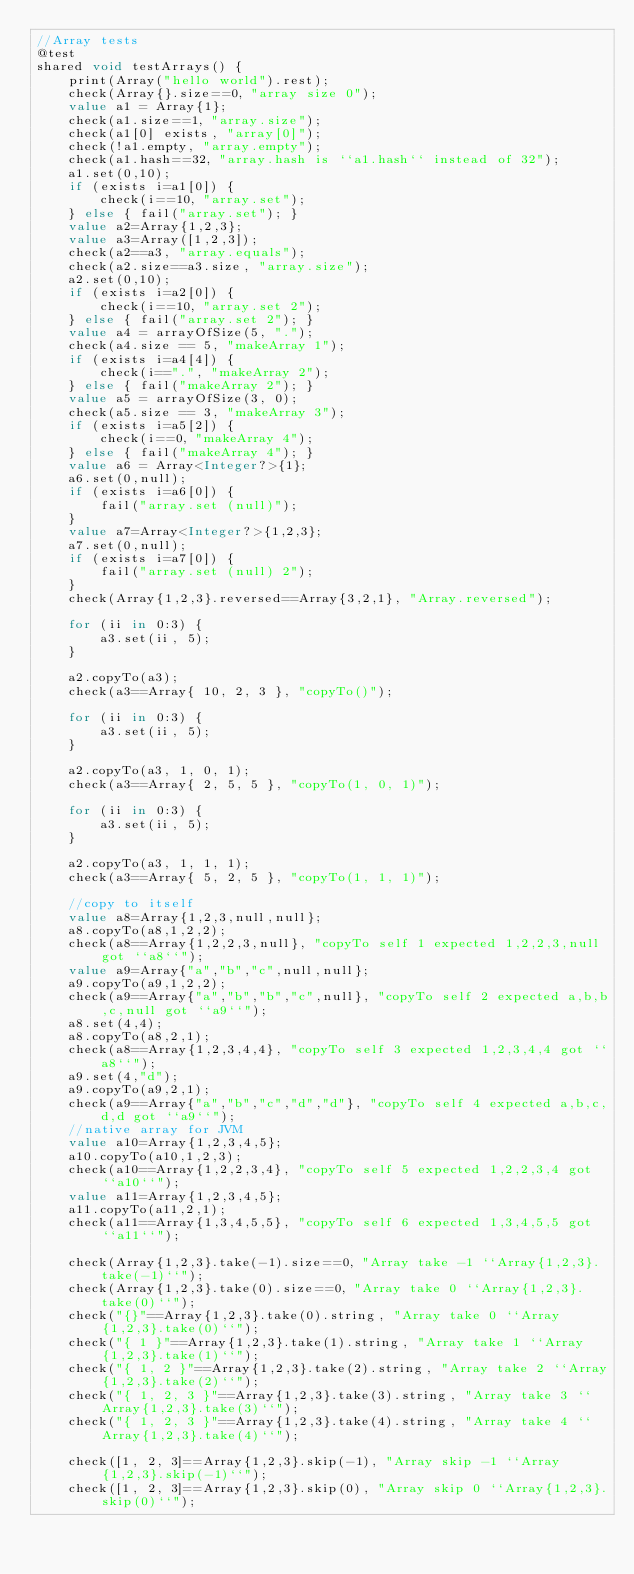Convert code to text. <code><loc_0><loc_0><loc_500><loc_500><_Ceylon_>//Array tests
@test
shared void testArrays() {
    print(Array("hello world").rest);
    check(Array{}.size==0, "array size 0");
    value a1 = Array{1};
    check(a1.size==1, "array.size");
    check(a1[0] exists, "array[0]");
    check(!a1.empty, "array.empty");
    check(a1.hash==32, "array.hash is ``a1.hash`` instead of 32");
    a1.set(0,10);
    if (exists i=a1[0]) {
        check(i==10, "array.set");
    } else { fail("array.set"); }
    value a2=Array{1,2,3};
    value a3=Array([1,2,3]);
    check(a2==a3, "array.equals");
    check(a2.size==a3.size, "array.size");
    a2.set(0,10);
    if (exists i=a2[0]) {
        check(i==10, "array.set 2");
    } else { fail("array.set 2"); }
    value a4 = arrayOfSize(5, ".");
    check(a4.size == 5, "makeArray 1");
    if (exists i=a4[4]) {
        check(i==".", "makeArray 2");
    } else { fail("makeArray 2"); }
    value a5 = arrayOfSize(3, 0);
    check(a5.size == 3, "makeArray 3");
    if (exists i=a5[2]) {
        check(i==0, "makeArray 4");
    } else { fail("makeArray 4"); }
    value a6 = Array<Integer?>{1};
    a6.set(0,null);
    if (exists i=a6[0]) {
        fail("array.set (null)");
    }
    value a7=Array<Integer?>{1,2,3};
    a7.set(0,null);
    if (exists i=a7[0]) {
        fail("array.set (null) 2");
    }
    check(Array{1,2,3}.reversed==Array{3,2,1}, "Array.reversed");
    
    for (ii in 0:3) {
        a3.set(ii, 5);
    }
    
    a2.copyTo(a3);
    check(a3==Array{ 10, 2, 3 }, "copyTo()");
    
    for (ii in 0:3) {
        a3.set(ii, 5);
    }
    
    a2.copyTo(a3, 1, 0, 1);
    check(a3==Array{ 2, 5, 5 }, "copyTo(1, 0, 1)");
    
    for (ii in 0:3) {
        a3.set(ii, 5);
    }
    
    a2.copyTo(a3, 1, 1, 1);
    check(a3==Array{ 5, 2, 5 }, "copyTo(1, 1, 1)");

    //copy to itself
    value a8=Array{1,2,3,null,null};
    a8.copyTo(a8,1,2,2);
    check(a8==Array{1,2,2,3,null}, "copyTo self 1 expected 1,2,2,3,null got ``a8``");
    value a9=Array{"a","b","c",null,null};
    a9.copyTo(a9,1,2,2);
    check(a9==Array{"a","b","b","c",null}, "copyTo self 2 expected a,b,b,c,null got ``a9``");
    a8.set(4,4);
    a8.copyTo(a8,2,1);
    check(a8==Array{1,2,3,4,4}, "copyTo self 3 expected 1,2,3,4,4 got ``a8``");
    a9.set(4,"d");
    a9.copyTo(a9,2,1);
    check(a9==Array{"a","b","c","d","d"}, "copyTo self 4 expected a,b,c,d,d got ``a9``");
    //native array for JVM
    value a10=Array{1,2,3,4,5};
    a10.copyTo(a10,1,2,3);
    check(a10==Array{1,2,2,3,4}, "copyTo self 5 expected 1,2,2,3,4 got ``a10``");
    value a11=Array{1,2,3,4,5};
    a11.copyTo(a11,2,1);
    check(a11==Array{1,3,4,5,5}, "copyTo self 6 expected 1,3,4,5,5 got ``a11``");
    
    check(Array{1,2,3}.take(-1).size==0, "Array take -1 ``Array{1,2,3}.take(-1)``");
    check(Array{1,2,3}.take(0).size==0, "Array take 0 ``Array{1,2,3}.take(0)``");
    check("{}"==Array{1,2,3}.take(0).string, "Array take 0 ``Array{1,2,3}.take(0)``");
    check("{ 1 }"==Array{1,2,3}.take(1).string, "Array take 1 ``Array{1,2,3}.take(1)``");
    check("{ 1, 2 }"==Array{1,2,3}.take(2).string, "Array take 2 ``Array{1,2,3}.take(2)``");
    check("{ 1, 2, 3 }"==Array{1,2,3}.take(3).string, "Array take 3 ``Array{1,2,3}.take(3)``");
    check("{ 1, 2, 3 }"==Array{1,2,3}.take(4).string, "Array take 4 ``Array{1,2,3}.take(4)``");
    
    check([1, 2, 3]==Array{1,2,3}.skip(-1), "Array skip -1 ``Array{1,2,3}.skip(-1)``");
    check([1, 2, 3]==Array{1,2,3}.skip(0), "Array skip 0 ``Array{1,2,3}.skip(0)``");</code> 